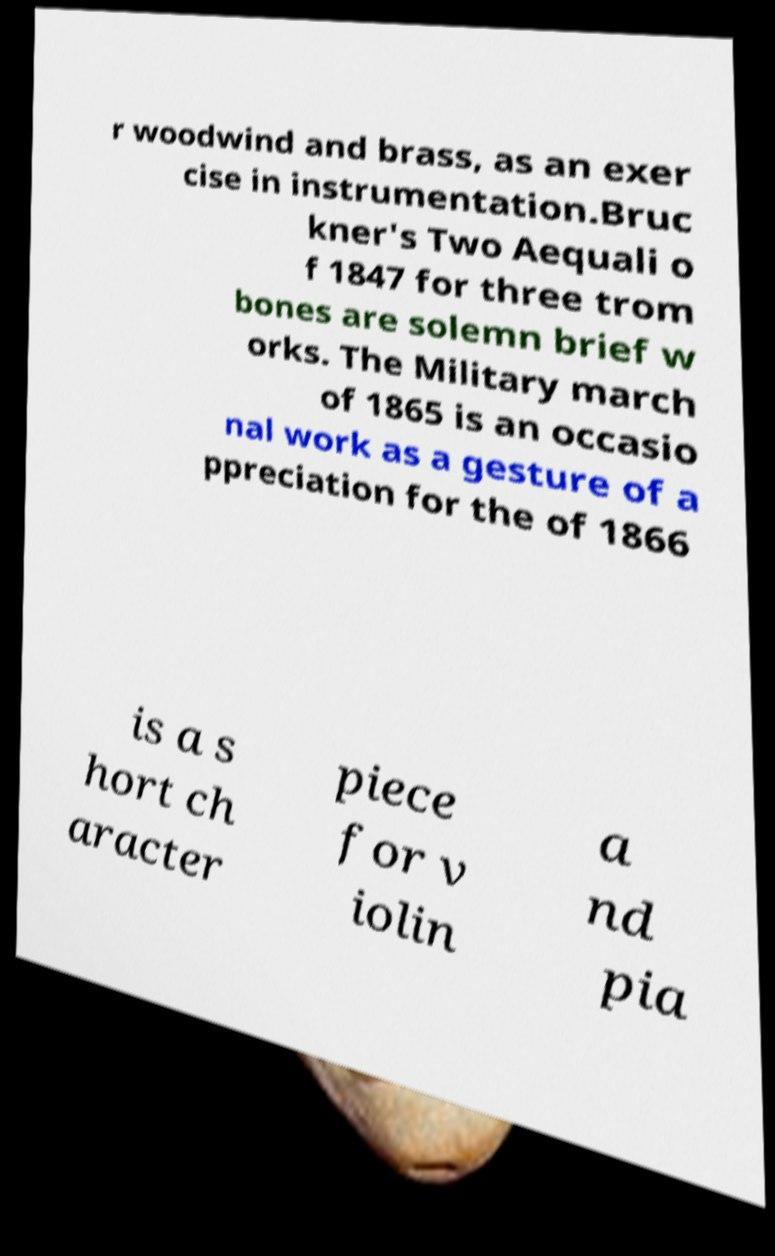I need the written content from this picture converted into text. Can you do that? r woodwind and brass, as an exer cise in instrumentation.Bruc kner's Two Aequali o f 1847 for three trom bones are solemn brief w orks. The Military march of 1865 is an occasio nal work as a gesture of a ppreciation for the of 1866 is a s hort ch aracter piece for v iolin a nd pia 